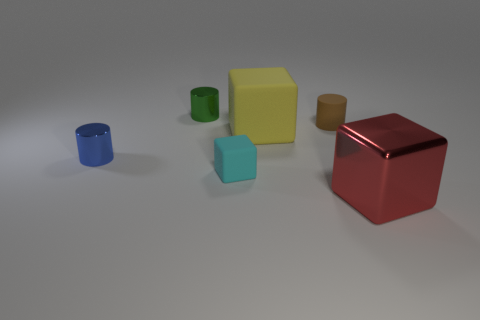Is the shape of the small green shiny object the same as the small matte thing to the left of the small brown cylinder?
Your response must be concise. No. How many shiny objects are behind the red thing?
Give a very brief answer. 2. There is a object in front of the cyan thing; does it have the same shape as the cyan object?
Your answer should be very brief. Yes. What color is the tiny metallic cylinder behind the brown thing?
Offer a terse response. Green. There is a brown object that is made of the same material as the big yellow object; what shape is it?
Provide a succinct answer. Cylinder. Are there more large blocks that are in front of the big yellow rubber block than large red blocks behind the brown cylinder?
Your answer should be very brief. Yes. What number of red objects have the same size as the red block?
Provide a succinct answer. 0. Are there fewer tiny cubes that are right of the tiny rubber cylinder than small brown rubber objects that are on the left side of the red cube?
Offer a terse response. Yes. Are there any other small objects of the same shape as the red metal thing?
Your response must be concise. Yes. Is the tiny blue thing the same shape as the brown rubber thing?
Your answer should be compact. Yes. 